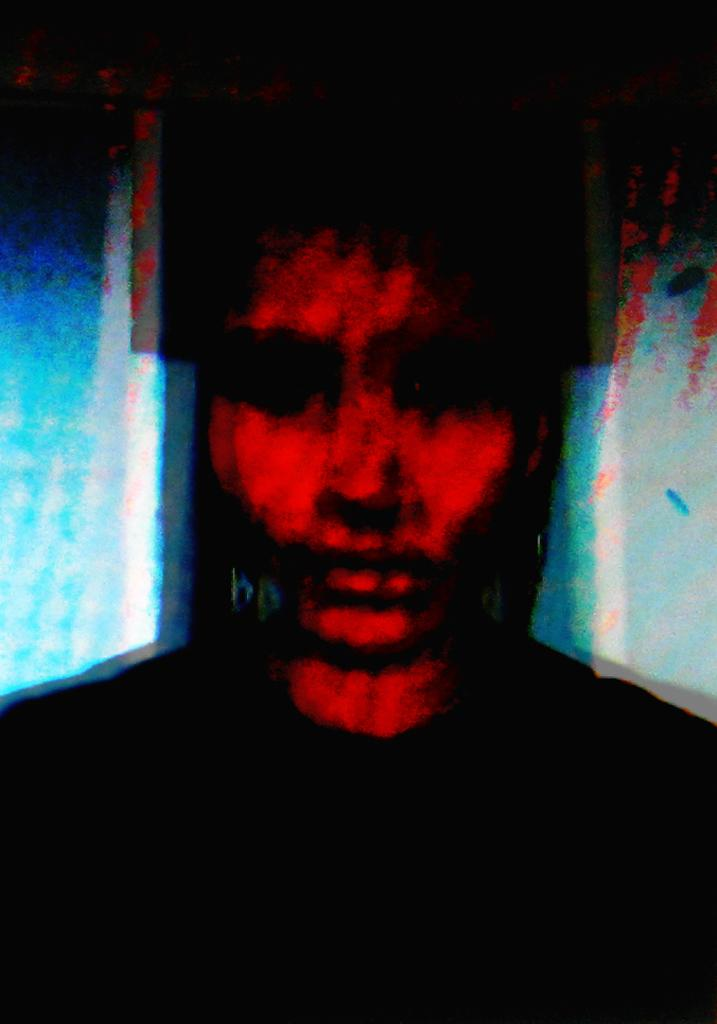What type of artwork is shown in the image? The image is a painting. Can you describe the subject matter of the painting? There is a person depicted in the painting. What breed of dog is sitting next to the person in the painting? There is no dog present in the painting; only a person is depicted. 